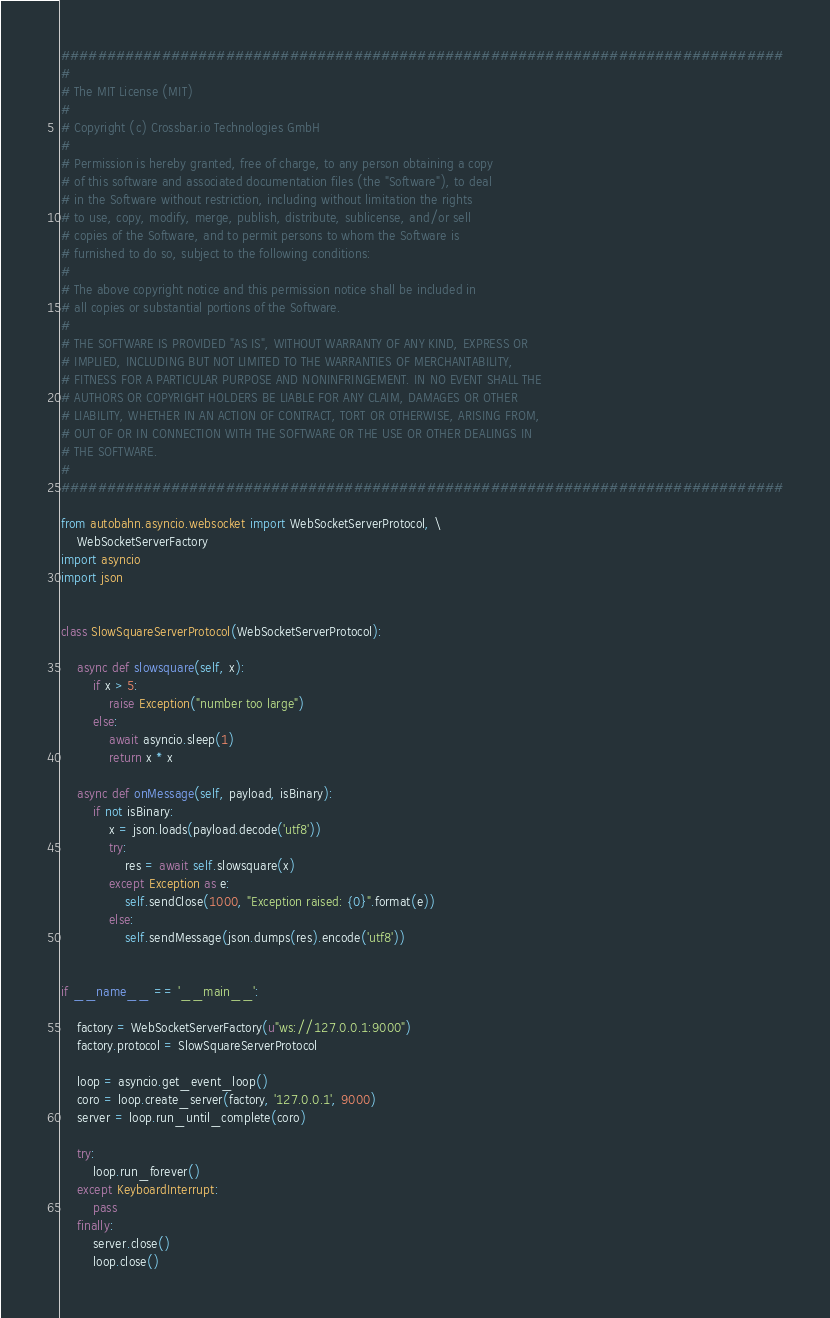<code> <loc_0><loc_0><loc_500><loc_500><_Python_>###############################################################################
#
# The MIT License (MIT)
#
# Copyright (c) Crossbar.io Technologies GmbH
#
# Permission is hereby granted, free of charge, to any person obtaining a copy
# of this software and associated documentation files (the "Software"), to deal
# in the Software without restriction, including without limitation the rights
# to use, copy, modify, merge, publish, distribute, sublicense, and/or sell
# copies of the Software, and to permit persons to whom the Software is
# furnished to do so, subject to the following conditions:
#
# The above copyright notice and this permission notice shall be included in
# all copies or substantial portions of the Software.
#
# THE SOFTWARE IS PROVIDED "AS IS", WITHOUT WARRANTY OF ANY KIND, EXPRESS OR
# IMPLIED, INCLUDING BUT NOT LIMITED TO THE WARRANTIES OF MERCHANTABILITY,
# FITNESS FOR A PARTICULAR PURPOSE AND NONINFRINGEMENT. IN NO EVENT SHALL THE
# AUTHORS OR COPYRIGHT HOLDERS BE LIABLE FOR ANY CLAIM, DAMAGES OR OTHER
# LIABILITY, WHETHER IN AN ACTION OF CONTRACT, TORT OR OTHERWISE, ARISING FROM,
# OUT OF OR IN CONNECTION WITH THE SOFTWARE OR THE USE OR OTHER DEALINGS IN
# THE SOFTWARE.
#
###############################################################################

from autobahn.asyncio.websocket import WebSocketServerProtocol, \
    WebSocketServerFactory
import asyncio
import json


class SlowSquareServerProtocol(WebSocketServerProtocol):

    async def slowsquare(self, x):
        if x > 5:
            raise Exception("number too large")
        else:
            await asyncio.sleep(1)
            return x * x

    async def onMessage(self, payload, isBinary):
        if not isBinary:
            x = json.loads(payload.decode('utf8'))
            try:
                res = await self.slowsquare(x)
            except Exception as e:
                self.sendClose(1000, "Exception raised: {0}".format(e))
            else:
                self.sendMessage(json.dumps(res).encode('utf8'))


if __name__ == '__main__':

    factory = WebSocketServerFactory(u"ws://127.0.0.1:9000")
    factory.protocol = SlowSquareServerProtocol

    loop = asyncio.get_event_loop()
    coro = loop.create_server(factory, '127.0.0.1', 9000)
    server = loop.run_until_complete(coro)

    try:
        loop.run_forever()
    except KeyboardInterrupt:
        pass
    finally:
        server.close()
        loop.close()
</code> 